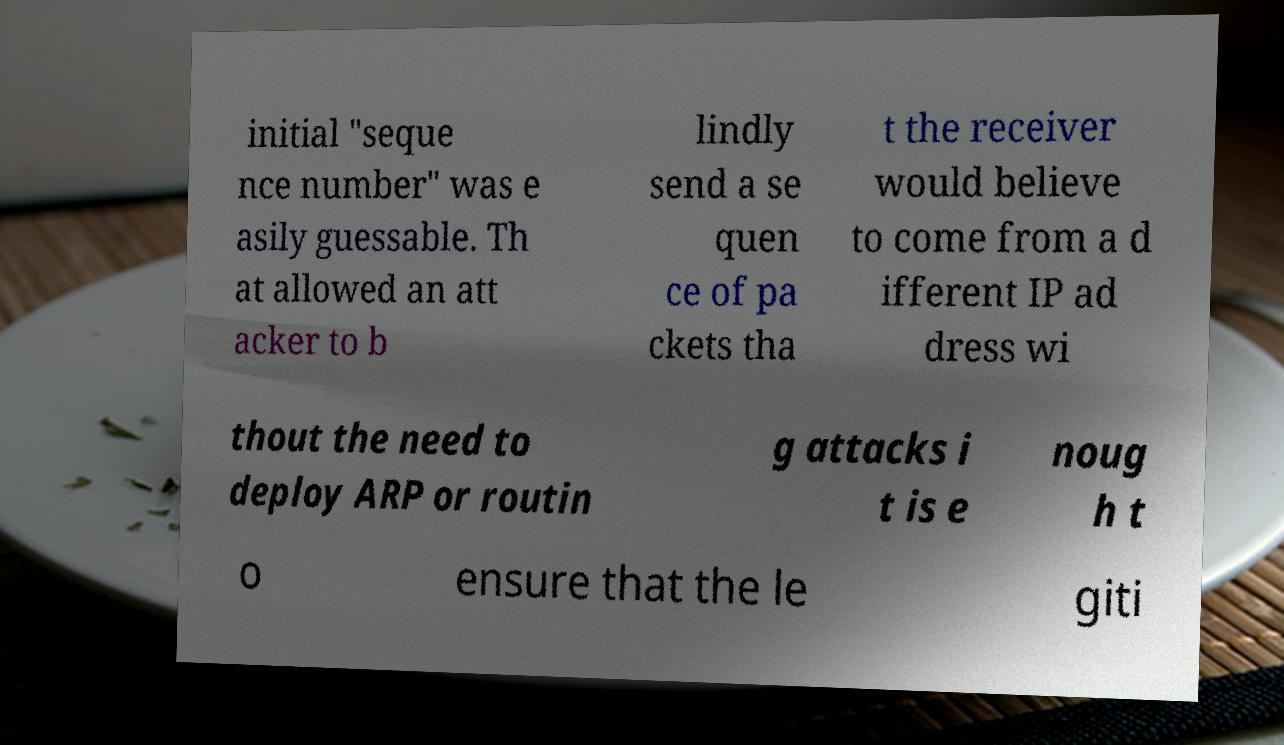Please identify and transcribe the text found in this image. initial "seque nce number" was e asily guessable. Th at allowed an att acker to b lindly send a se quen ce of pa ckets tha t the receiver would believe to come from a d ifferent IP ad dress wi thout the need to deploy ARP or routin g attacks i t is e noug h t o ensure that the le giti 